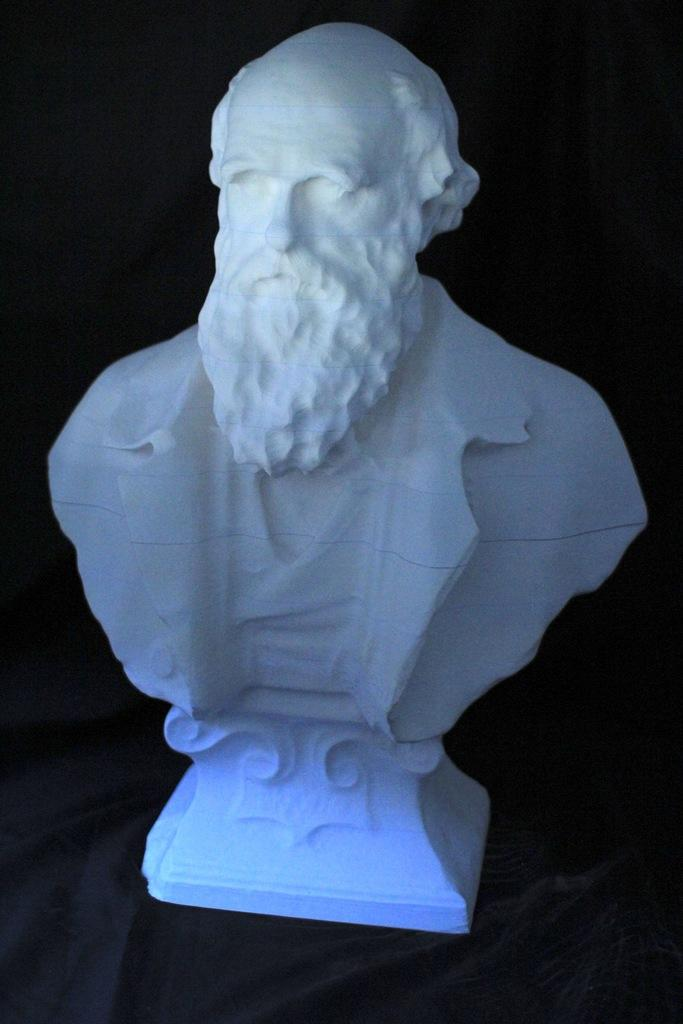What is the main subject of the image? There is a sculpture in the image. Can you describe the appearance of the sculpture? The sculpture is white in color. What type of wound can be seen on the sculpture in the image? There is no wound present on the sculpture in the image. Is there a knife visible in the image? There is no knife present in the image. 